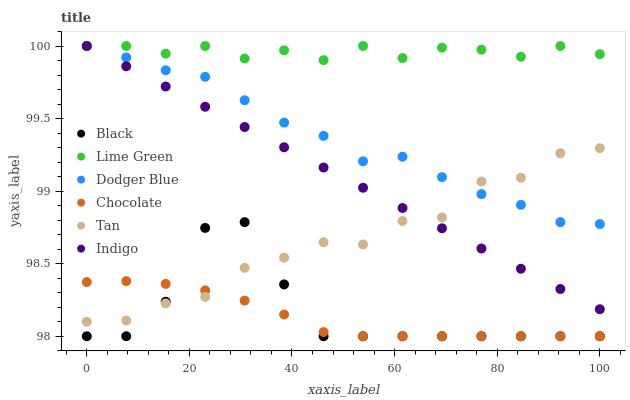Does Chocolate have the minimum area under the curve?
Answer yes or no. Yes. Does Lime Green have the maximum area under the curve?
Answer yes or no. Yes. Does Black have the minimum area under the curve?
Answer yes or no. No. Does Black have the maximum area under the curve?
Answer yes or no. No. Is Indigo the smoothest?
Answer yes or no. Yes. Is Black the roughest?
Answer yes or no. Yes. Is Chocolate the smoothest?
Answer yes or no. No. Is Chocolate the roughest?
Answer yes or no. No. Does Chocolate have the lowest value?
Answer yes or no. Yes. Does Dodger Blue have the lowest value?
Answer yes or no. No. Does Lime Green have the highest value?
Answer yes or no. Yes. Does Black have the highest value?
Answer yes or no. No. Is Black less than Dodger Blue?
Answer yes or no. Yes. Is Indigo greater than Black?
Answer yes or no. Yes. Does Chocolate intersect Black?
Answer yes or no. Yes. Is Chocolate less than Black?
Answer yes or no. No. Is Chocolate greater than Black?
Answer yes or no. No. Does Black intersect Dodger Blue?
Answer yes or no. No. 